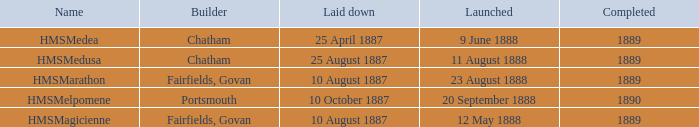Which builder completed before 1890 and launched on 9 june 1888? Chatham. 